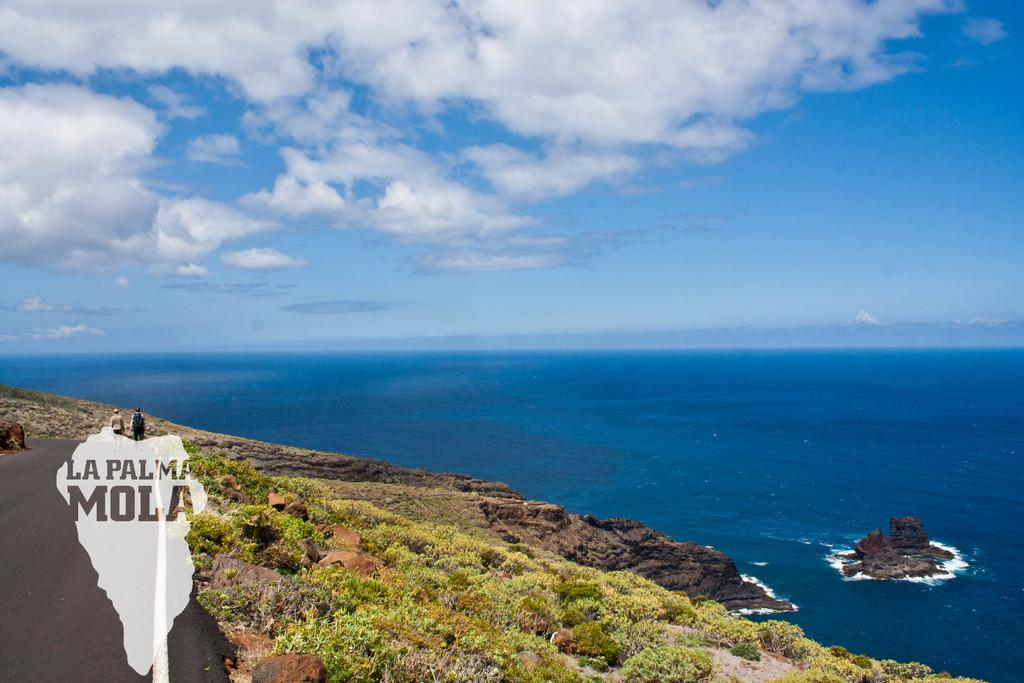What type of vegetation or plants can be seen at the bottom of the image? There is greenery at the bottom side of the image. What large body of water is visible in the image? There is a sea in the center of the image. What type of badge is being worn by the sea in the image? There is no badge present in the image, as the sea is a large body of water and not a person or object that could wear a badge. 